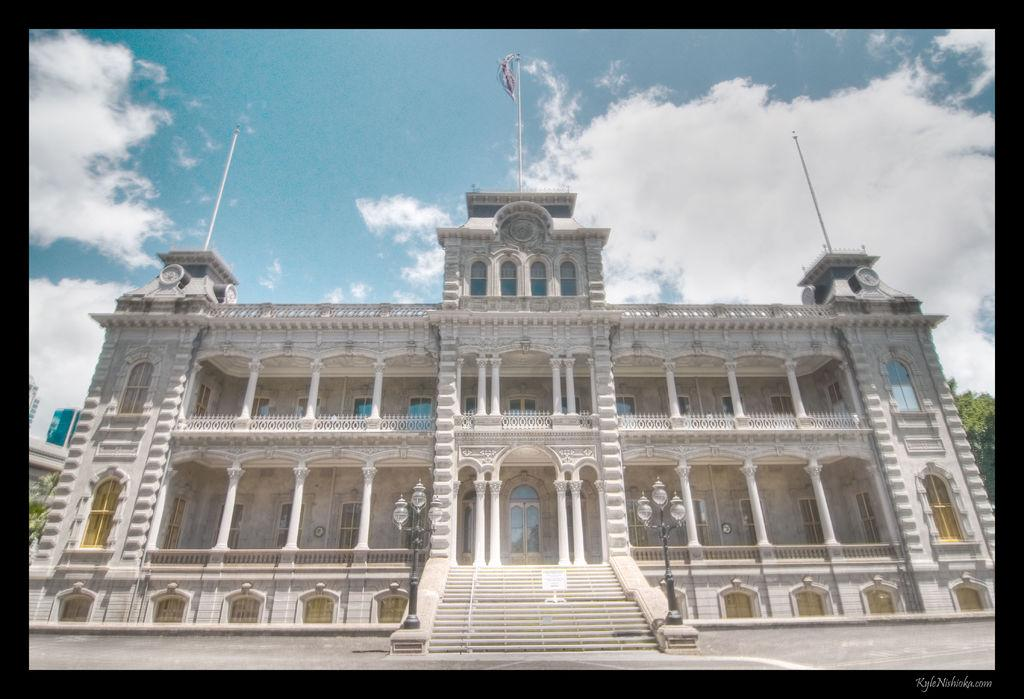What type of structure is visible in the image? There is a building in the image. What features can be seen on the building? The building has windows, doors, and a staircase. Are there any other objects near the building? Yes, there are poles near the building. How many light poles are present in the image? There are two light poles in the image. What is attached to one of the poles? There is a flag on a pole. What can be seen in the background of the image? There are trees and a cloudy sky in the background. How fast does the snail move across the building in the image? There is no snail present in the image, so it is not possible to determine its speed. 